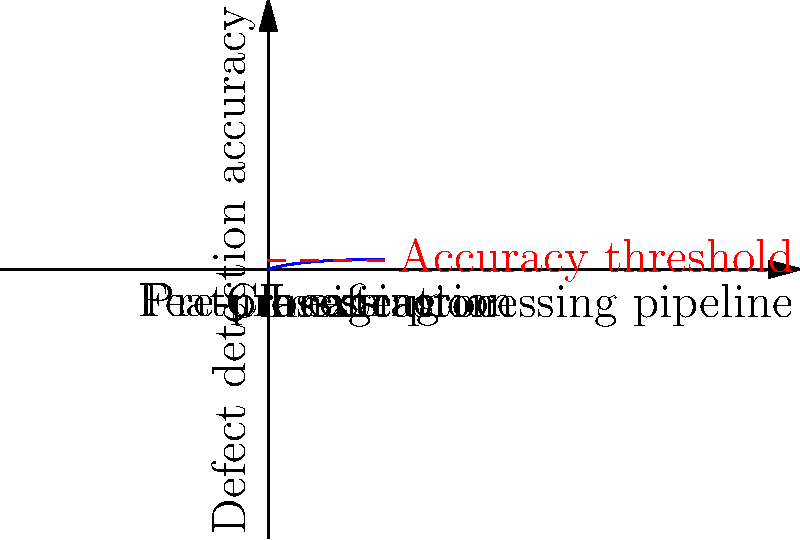In the context of defect detection in manufactured components using computer vision, the graph shows the relationship between the image processing pipeline stages and defect detection accuracy. What critical observation can be made about the classification stage, and how might this inform the allocation of computational resources in the pipeline? To answer this question, let's analyze the graph step-by-step:

1. The x-axis represents the image processing pipeline, divided into three main stages: pre-processing, feature extraction, and classification.

2. The y-axis represents the defect detection accuracy, with a red dashed line indicating an accuracy threshold.

3. The blue curve shows how the accuracy improves as we progress through the pipeline:

   a. In the pre-processing stage, there's a sharp increase in accuracy.
   b. During feature extraction, the accuracy continues to improve but at a slower rate.
   c. In the classification stage, the curve starts to flatten out, approaching an asymptote.

4. The critical observation about the classification stage is that it shows diminishing returns in terms of accuracy improvement. The curve is almost flat in this region, indicating that additional computational effort in this stage may not yield significant improvements in accuracy.

5. This observation can inform resource allocation in the following ways:

   a. More computational resources should be allocated to the pre-processing and feature extraction stages, where the impact on accuracy is more substantial.
   b. For the classification stage, it might be more efficient to use simpler, less computationally intensive algorithms that achieve close to the maximum accuracy without excessive processing.
   c. If the accuracy is already above the threshold by the end of the feature extraction stage, it may be possible to skip or simplify the classification stage in some cases.

6. This approach aligns with the principle of diminishing returns in optimization, where the cost of additional improvements becomes increasingly high as we approach the theoretical maximum performance.
Answer: Diminishing returns in classification stage; allocate more resources to pre-processing and feature extraction. 